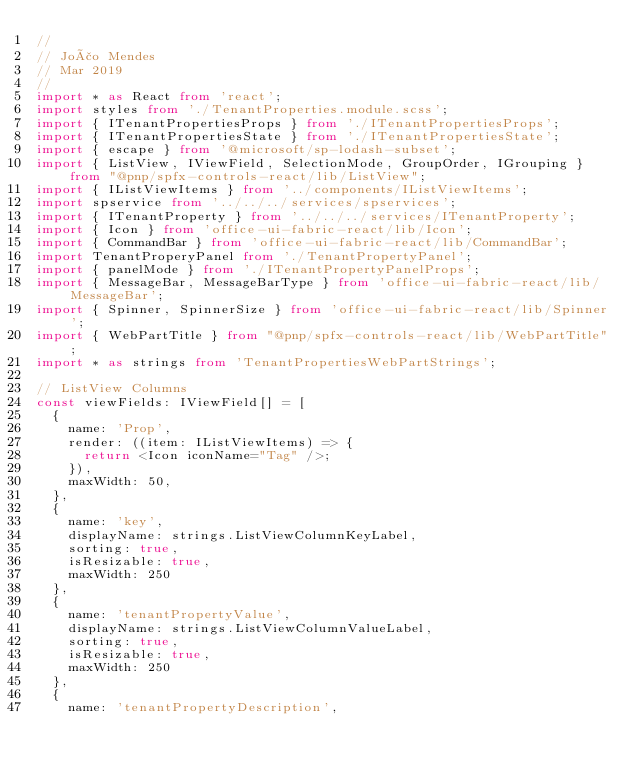<code> <loc_0><loc_0><loc_500><loc_500><_TypeScript_>//
// João Mendes
// Mar 2019
//
import * as React from 'react';
import styles from './TenantProperties.module.scss';
import { ITenantPropertiesProps } from './ITenantPropertiesProps';
import { ITenantPropertiesState } from './ITenantPropertiesState';
import { escape } from '@microsoft/sp-lodash-subset';
import { ListView, IViewField, SelectionMode, GroupOrder, IGrouping } from "@pnp/spfx-controls-react/lib/ListView";
import { IListViewItems } from '../components/IListViewItems';
import spservice from '../../../services/spservices';
import { ITenantProperty } from '../../../services/ITenantProperty';
import { Icon } from 'office-ui-fabric-react/lib/Icon';
import { CommandBar } from 'office-ui-fabric-react/lib/CommandBar';
import TenantProperyPanel from './TenantPropertyPanel';
import { panelMode } from './ITenantPropertyPanelProps';
import { MessageBar, MessageBarType } from 'office-ui-fabric-react/lib/MessageBar';
import { Spinner, SpinnerSize } from 'office-ui-fabric-react/lib/Spinner';
import { WebPartTitle } from "@pnp/spfx-controls-react/lib/WebPartTitle";
import * as strings from 'TenantPropertiesWebPartStrings';

// ListView Columns
const viewFields: IViewField[] = [
  {
    name: 'Prop',
    render: ((item: IListViewItems) => {
      return <Icon iconName="Tag" />;
    }),
    maxWidth: 50,
  },
  {
    name: 'key',
    displayName: strings.ListViewColumnKeyLabel,
    sorting: true,
    isResizable: true,
    maxWidth: 250
  },
  {
    name: 'tenantPropertyValue',
    displayName: strings.ListViewColumnValueLabel,
    sorting: true,
    isResizable: true,
    maxWidth: 250
  },
  {
    name: 'tenantPropertyDescription',</code> 